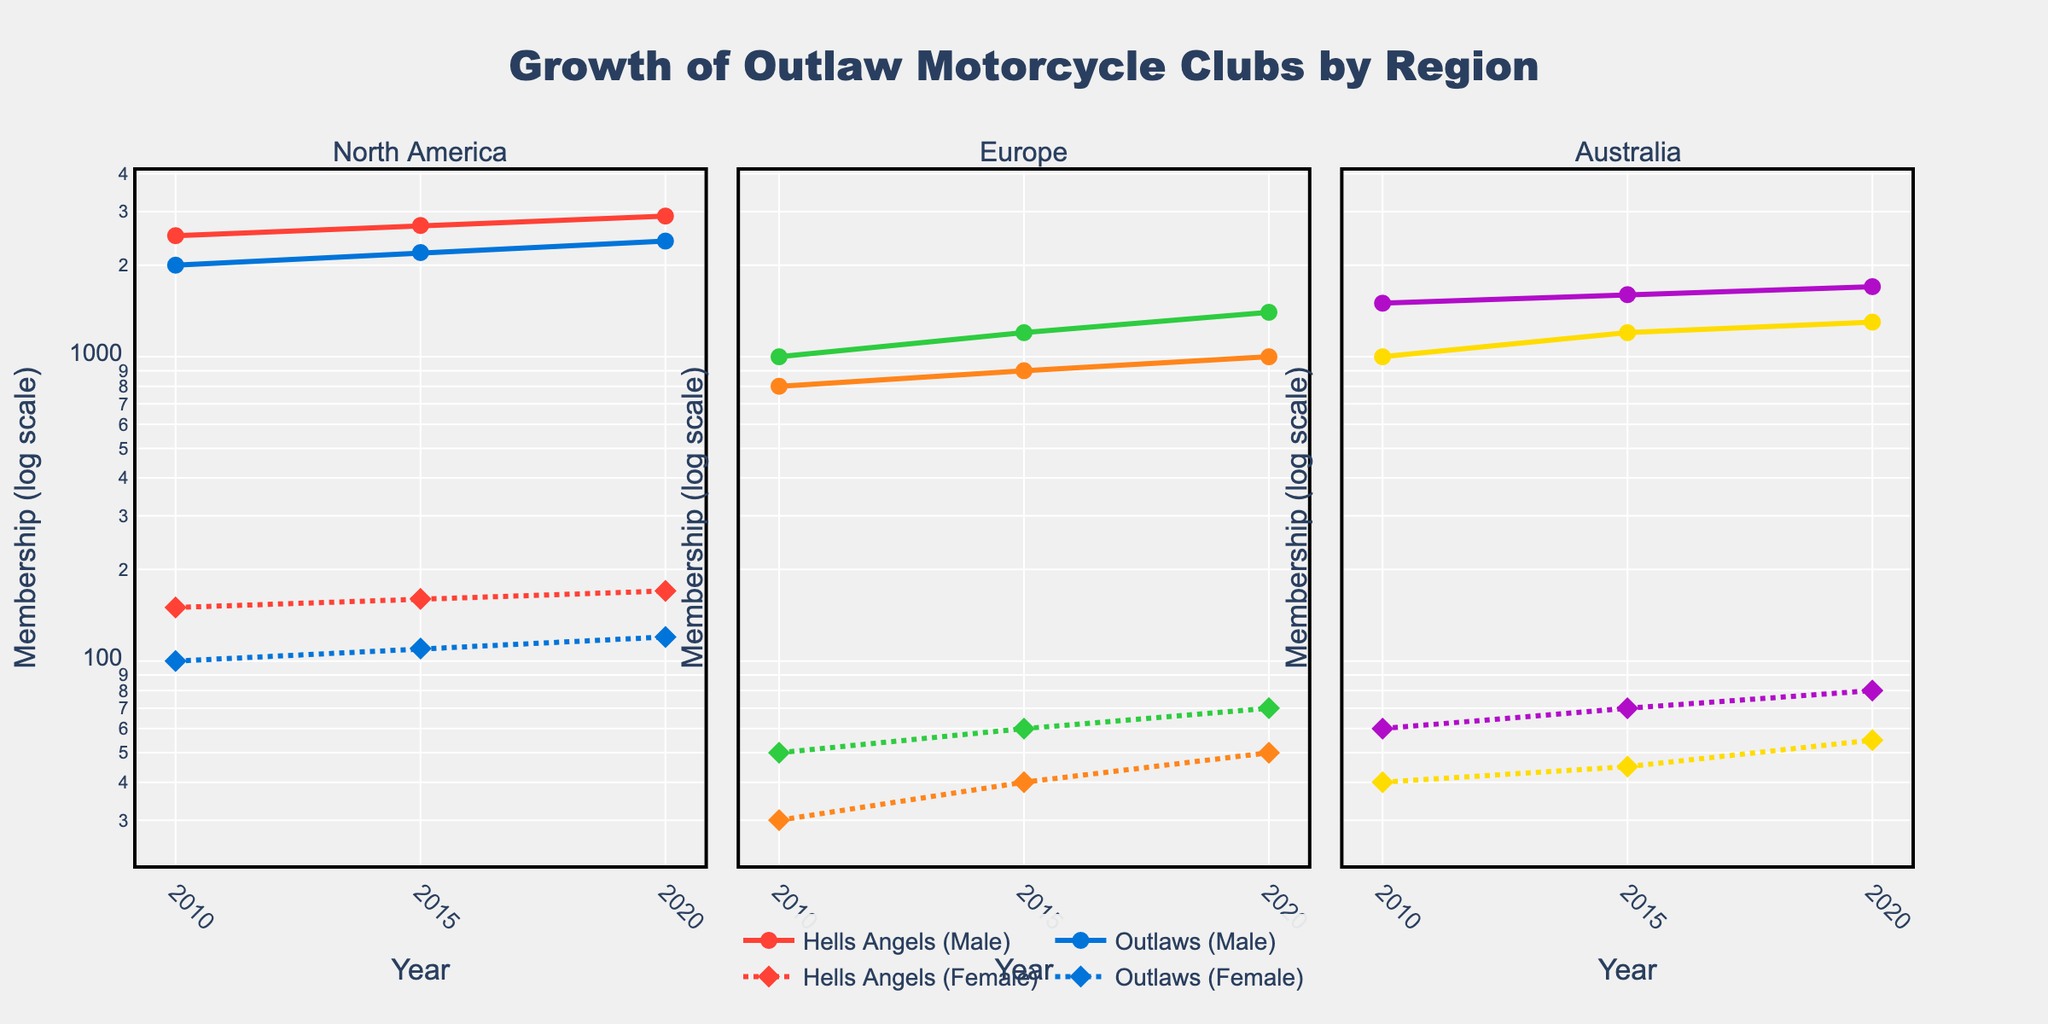What region shows the highest male membership growth for the Hells Angels from 2010 to 2020? In the North America region subplot, observe the lines for male membership of the Hells Angels. The membership increases from 2500 in 2010 to 2900 in 2020.
Answer: North America How does the male membership of the Outlaws in North America compare between 2010 and 2015? In the North America subplot, note the male membership of the Outlaws in 2010 and 2015. It increases from 2000 in 2010 to 2200 in 2015.
Answer: The membership increased Which gang in Europe shows the smallest growth in female membership from 2010 to 2020? In the Europe subplot, compare the female membership growth for each gang. The Mongols increase from 30 in 2010 to 50 in 2020, while Bandidos grow from 50 to 70.
Answer: Mongols What is the trend for female membership of the Rebels in Australia from 2010 to 2020? In the Australia subplot, observe the line for female membership of the Rebels. Membership increases from 60 in 2010 to 80 in 2020 in a consistent upward trend.
Answer: Increasing What does the subplot title indicate for each of the regions? Each subplot title indicates the region depicted, which is either North America, Europe, or Australia.
Answer: Region names (North America, Europe, Australia) Which gang in Europe had a higher male membership in 2015, Bandidos or Mongols? In the Europe subplot, look at the data points for male membership of the Bandidos and Mongols in 2015. Bandidos have 1200 and Mongols have 900.
Answer: Bandidos How does the female membership of the Hells Angels in North America in 2020 compare to the female membership of Vikings in Australia? Compare the female membership values in the respective subplots for 2020. Hells Angels in North America have 170 members, while Vikings in Australia have 55.
Answer: Hells Angels have higher Did the number of subgroups for Outlaws in North America increase or decrease from 2010 to 2015? Although the visual focuses on membership, the question implies analyzing supporting data trends. According to the dataset, subgroups for Outlaws increased from 30 to 35.
Answer: Increased How are the male and female memberships represented in the plot? Male memberships are represented with solid lines and circle markers, whereas female memberships are represented with dotted lines and diamond markers.
Answer: Solid lines for males, dotted lines for females What is the y-axis scale used in the plot? The y-axis uses a logarithmic scale as indicated by the axis title "Membership (log scale)".
Answer: Logarithmic scale 